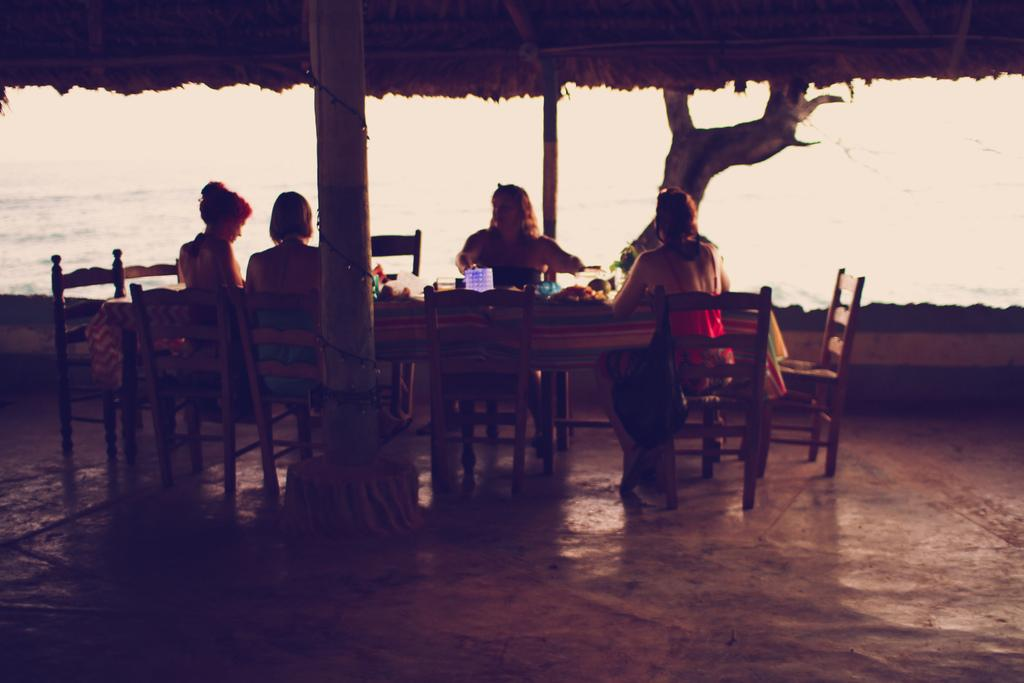What are the people in the image doing? The people in the image are sitting on chairs. What is in front of the people? There is a table in front of the people. What is covering the table? The table has a cloth on it. What can be seen on the table? There are objects on the table. What natural element is visible in the image? There is water visible in the image. What type of plant is present in the image? There is a tree in the image. What type of veil is draped over the sister's locket in the image? There is no veil or sister present in the image, nor is there any mention of a locket. 